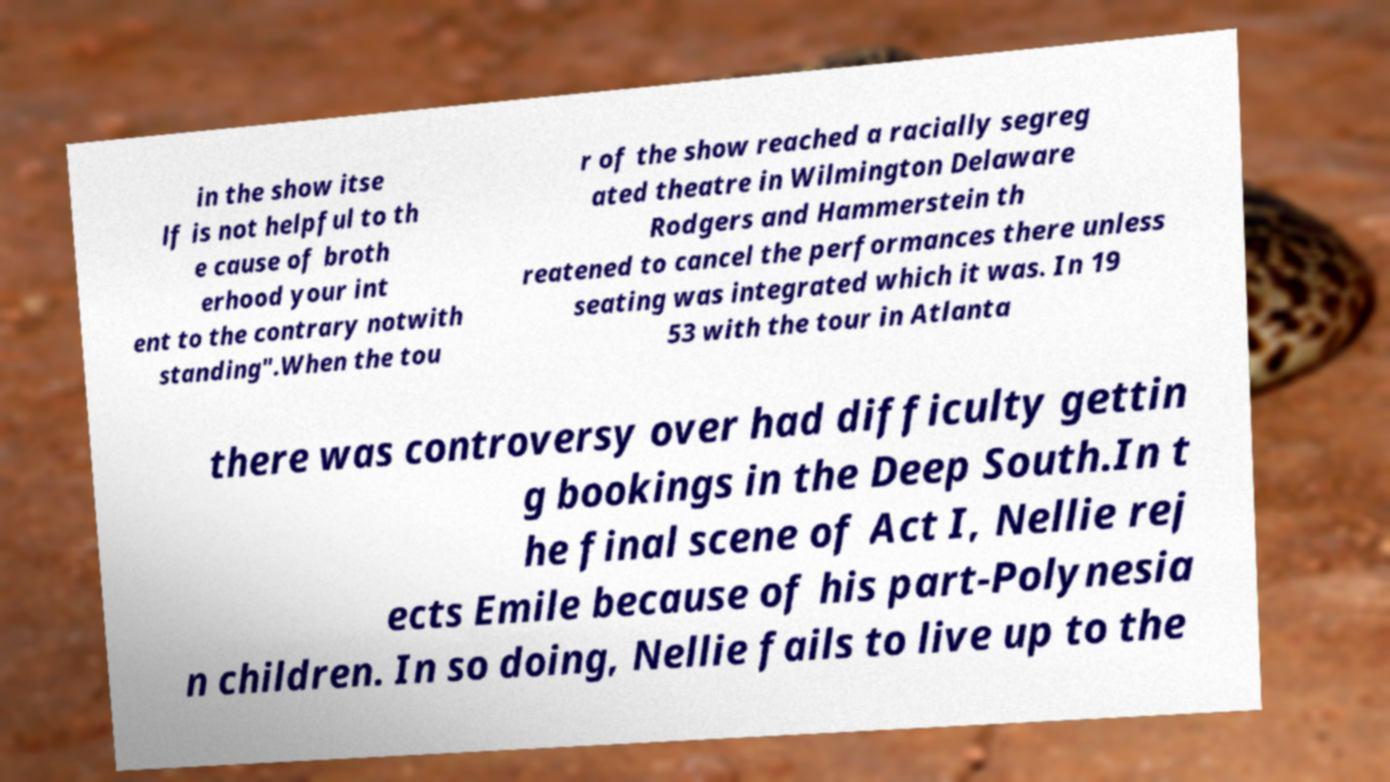Please read and relay the text visible in this image. What does it say? in the show itse lf is not helpful to th e cause of broth erhood your int ent to the contrary notwith standing".When the tou r of the show reached a racially segreg ated theatre in Wilmington Delaware Rodgers and Hammerstein th reatened to cancel the performances there unless seating was integrated which it was. In 19 53 with the tour in Atlanta there was controversy over had difficulty gettin g bookings in the Deep South.In t he final scene of Act I, Nellie rej ects Emile because of his part-Polynesia n children. In so doing, Nellie fails to live up to the 